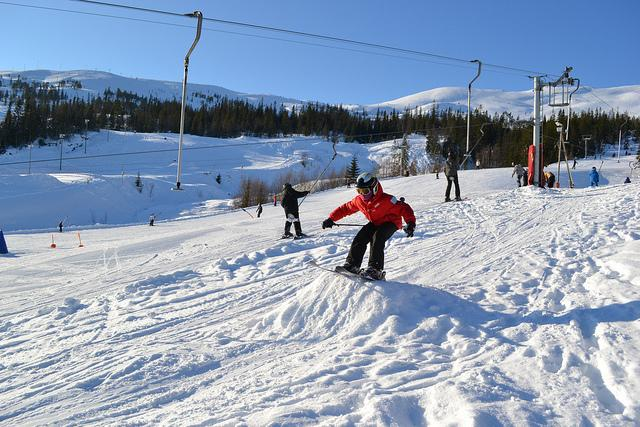After traversing over the jump what natural force will cause the boarder to return to the ground?

Choices:
A) gravity
B) inertia
C) fission
D) kinetic energy gravity 